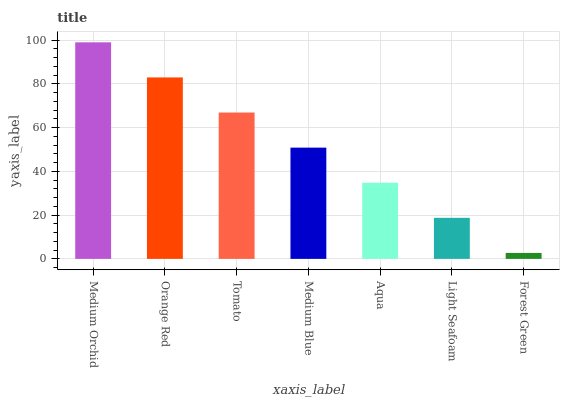Is Forest Green the minimum?
Answer yes or no. Yes. Is Medium Orchid the maximum?
Answer yes or no. Yes. Is Orange Red the minimum?
Answer yes or no. No. Is Orange Red the maximum?
Answer yes or no. No. Is Medium Orchid greater than Orange Red?
Answer yes or no. Yes. Is Orange Red less than Medium Orchid?
Answer yes or no. Yes. Is Orange Red greater than Medium Orchid?
Answer yes or no. No. Is Medium Orchid less than Orange Red?
Answer yes or no. No. Is Medium Blue the high median?
Answer yes or no. Yes. Is Medium Blue the low median?
Answer yes or no. Yes. Is Orange Red the high median?
Answer yes or no. No. Is Aqua the low median?
Answer yes or no. No. 